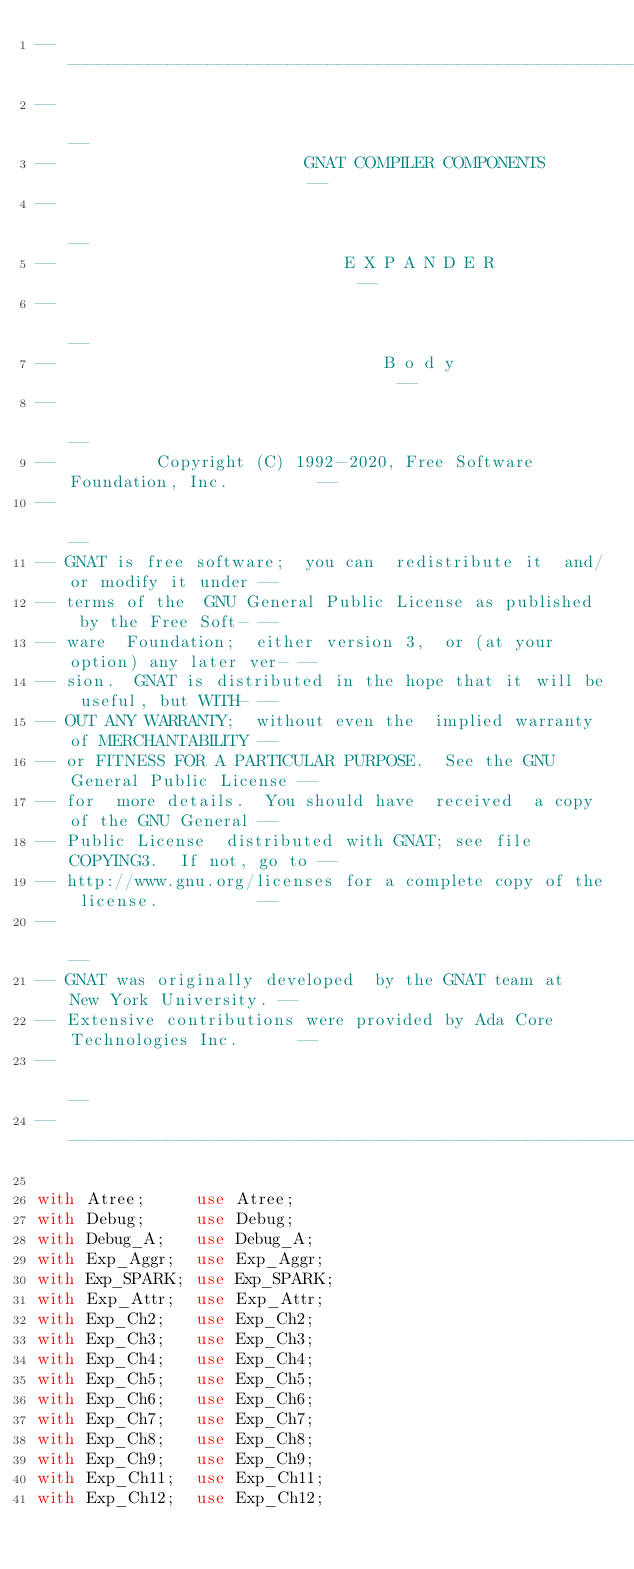Convert code to text. <code><loc_0><loc_0><loc_500><loc_500><_Ada_>------------------------------------------------------------------------------
--                                                                          --
--                         GNAT COMPILER COMPONENTS                         --
--                                                                          --
--                             E X P A N D E R                              --
--                                                                          --
--                                 B o d y                                  --
--                                                                          --
--          Copyright (C) 1992-2020, Free Software Foundation, Inc.         --
--                                                                          --
-- GNAT is free software;  you can  redistribute it  and/or modify it under --
-- terms of the  GNU General Public License as published  by the Free Soft- --
-- ware  Foundation;  either version 3,  or (at your option) any later ver- --
-- sion.  GNAT is distributed in the hope that it will be useful, but WITH- --
-- OUT ANY WARRANTY;  without even the  implied warranty of MERCHANTABILITY --
-- or FITNESS FOR A PARTICULAR PURPOSE.  See the GNU General Public License --
-- for  more details.  You should have  received  a copy of the GNU General --
-- Public License  distributed with GNAT; see file COPYING3.  If not, go to --
-- http://www.gnu.org/licenses for a complete copy of the license.          --
--                                                                          --
-- GNAT was originally developed  by the GNAT team at  New York University. --
-- Extensive contributions were provided by Ada Core Technologies Inc.      --
--                                                                          --
------------------------------------------------------------------------------

with Atree;     use Atree;
with Debug;     use Debug;
with Debug_A;   use Debug_A;
with Exp_Aggr;  use Exp_Aggr;
with Exp_SPARK; use Exp_SPARK;
with Exp_Attr;  use Exp_Attr;
with Exp_Ch2;   use Exp_Ch2;
with Exp_Ch3;   use Exp_Ch3;
with Exp_Ch4;   use Exp_Ch4;
with Exp_Ch5;   use Exp_Ch5;
with Exp_Ch6;   use Exp_Ch6;
with Exp_Ch7;   use Exp_Ch7;
with Exp_Ch8;   use Exp_Ch8;
with Exp_Ch9;   use Exp_Ch9;
with Exp_Ch11;  use Exp_Ch11;
with Exp_Ch12;  use Exp_Ch12;</code> 